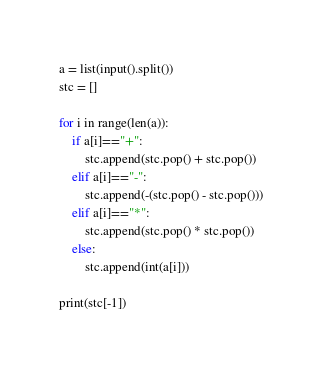<code> <loc_0><loc_0><loc_500><loc_500><_Python_>
a = list(input().split())
stc = []

for i in range(len(a)):
    if a[i]=="+":
        stc.append(stc.pop() + stc.pop())
    elif a[i]=="-":
        stc.append(-(stc.pop() - stc.pop()))
    elif a[i]=="*":
        stc.append(stc.pop() * stc.pop())
    else:
        stc.append(int(a[i]))
        
print(stc[-1])
</code> 